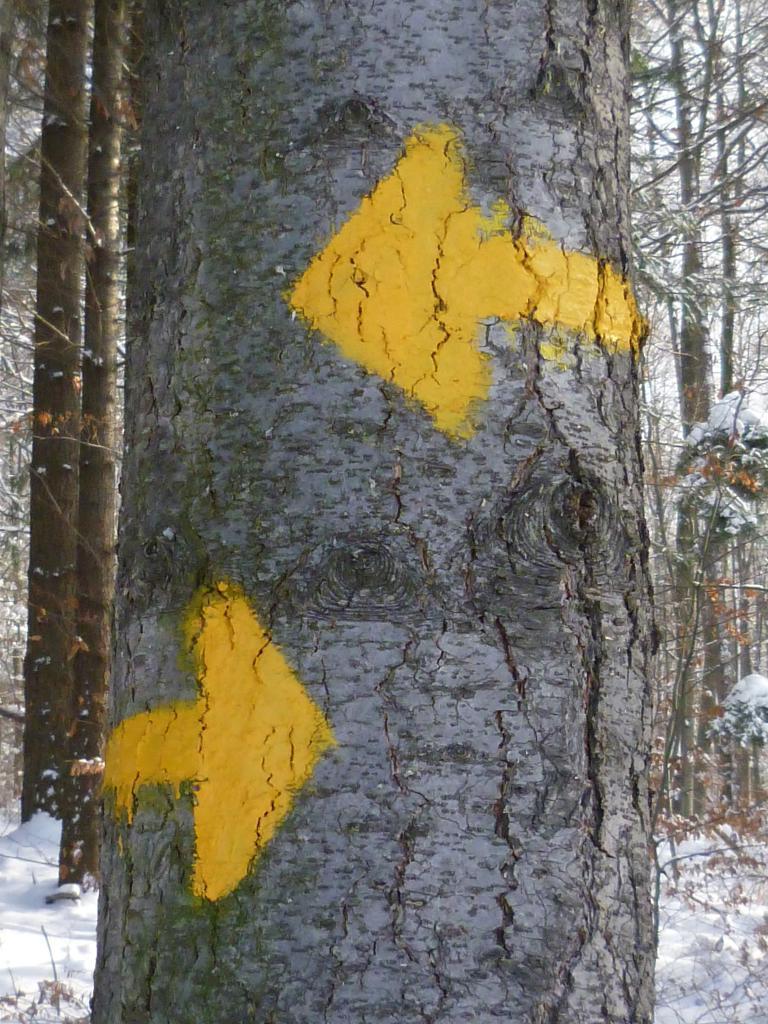Can you describe this image briefly? In the center of the image there is a tree. In the background we can see snow and trees. 